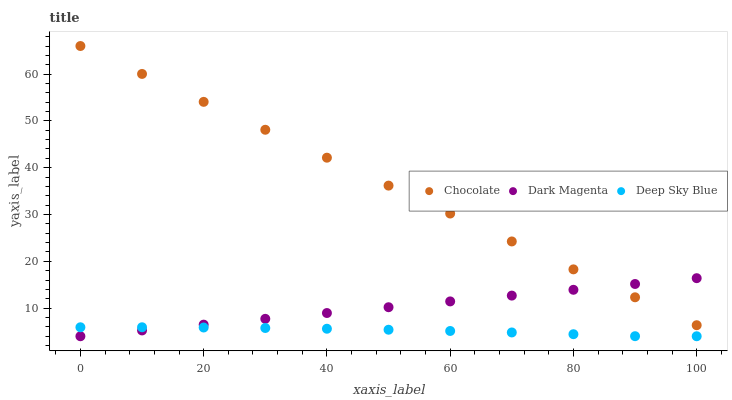Does Deep Sky Blue have the minimum area under the curve?
Answer yes or no. Yes. Does Chocolate have the maximum area under the curve?
Answer yes or no. Yes. Does Chocolate have the minimum area under the curve?
Answer yes or no. No. Does Deep Sky Blue have the maximum area under the curve?
Answer yes or no. No. Is Dark Magenta the smoothest?
Answer yes or no. Yes. Is Deep Sky Blue the roughest?
Answer yes or no. Yes. Is Chocolate the smoothest?
Answer yes or no. No. Is Chocolate the roughest?
Answer yes or no. No. Does Dark Magenta have the lowest value?
Answer yes or no. Yes. Does Chocolate have the lowest value?
Answer yes or no. No. Does Chocolate have the highest value?
Answer yes or no. Yes. Does Deep Sky Blue have the highest value?
Answer yes or no. No. Is Deep Sky Blue less than Chocolate?
Answer yes or no. Yes. Is Chocolate greater than Deep Sky Blue?
Answer yes or no. Yes. Does Dark Magenta intersect Chocolate?
Answer yes or no. Yes. Is Dark Magenta less than Chocolate?
Answer yes or no. No. Is Dark Magenta greater than Chocolate?
Answer yes or no. No. Does Deep Sky Blue intersect Chocolate?
Answer yes or no. No. 